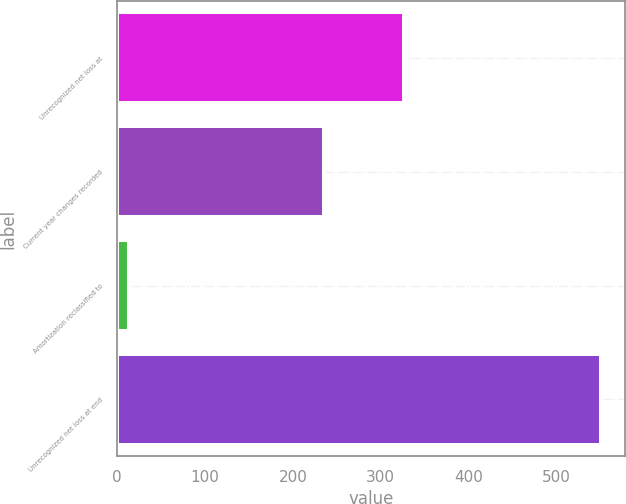Convert chart to OTSL. <chart><loc_0><loc_0><loc_500><loc_500><bar_chart><fcel>Unrecognized net loss at<fcel>Current year changes recorded<fcel>Amortization reclassified to<fcel>Unrecognized net loss at end<nl><fcel>326<fcel>235<fcel>13<fcel>551<nl></chart> 